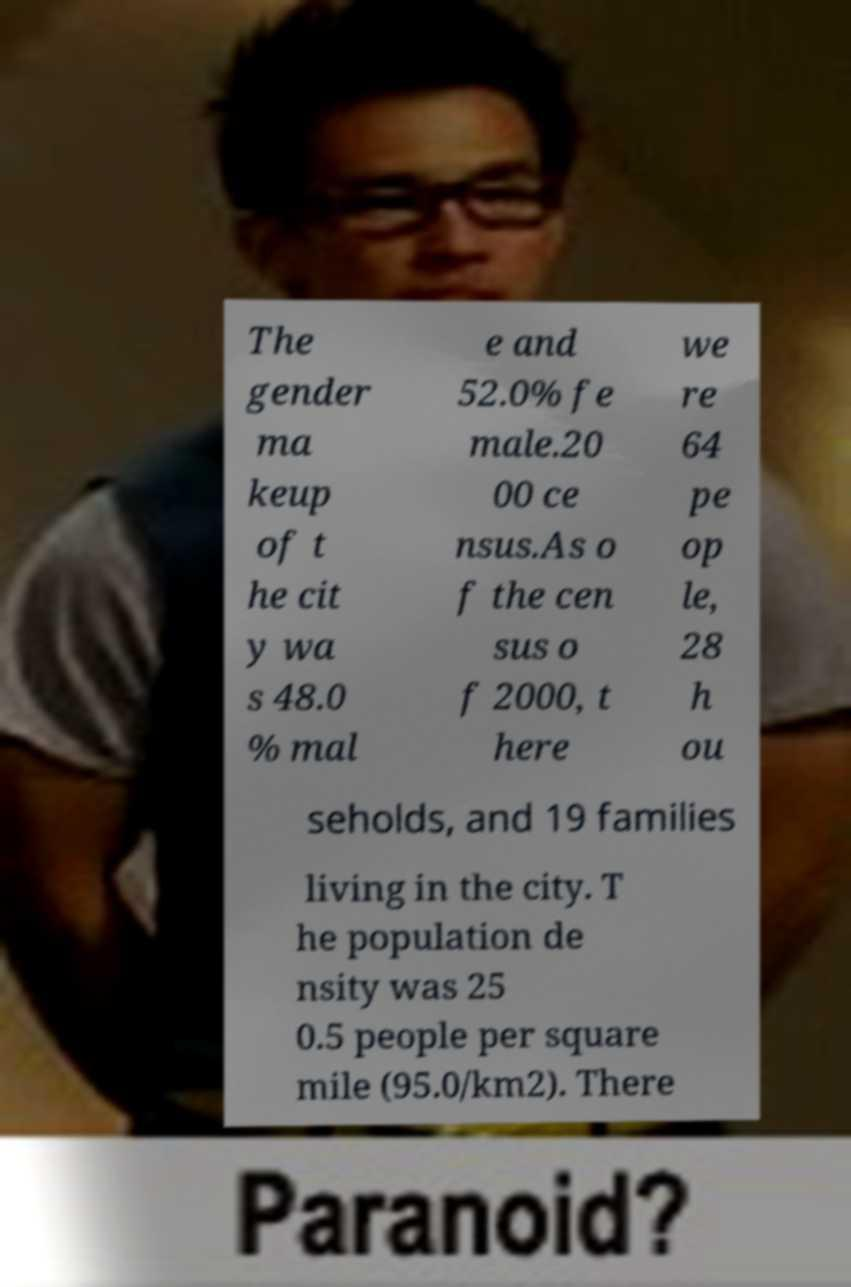I need the written content from this picture converted into text. Can you do that? The gender ma keup of t he cit y wa s 48.0 % mal e and 52.0% fe male.20 00 ce nsus.As o f the cen sus o f 2000, t here we re 64 pe op le, 28 h ou seholds, and 19 families living in the city. T he population de nsity was 25 0.5 people per square mile (95.0/km2). There 